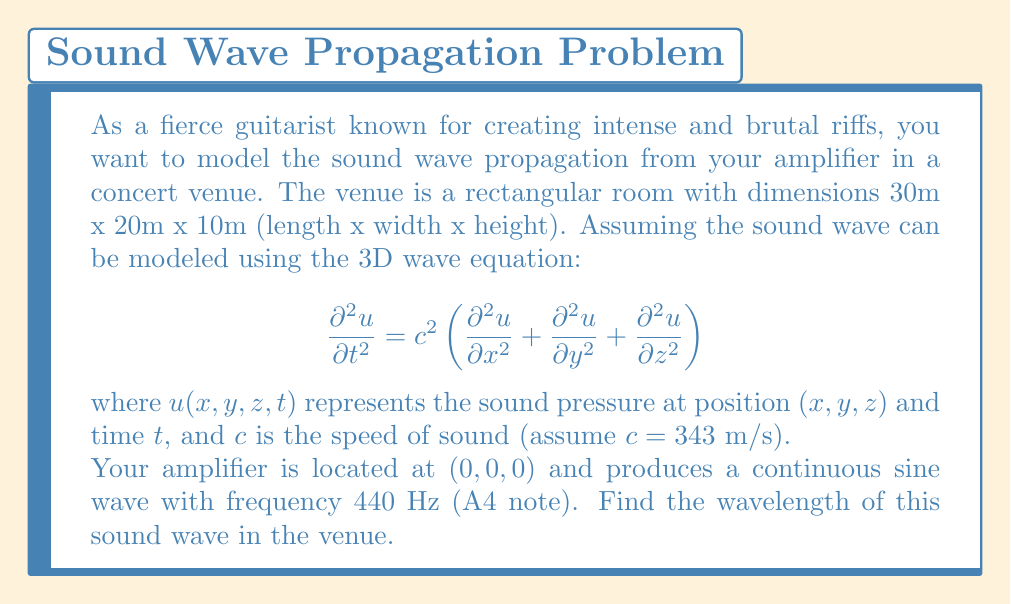Provide a solution to this math problem. To solve this problem, we need to understand the relationship between frequency, wavelength, and the speed of sound. The wave equation given describes how the sound wave propagates in three-dimensional space.

1) First, recall the relationship between frequency ($f$), wavelength ($\lambda$), and wave speed ($c$):

   $$c = f \lambda$$

2) We are given:
   - Frequency, $f = 440$ Hz
   - Speed of sound, $c = 343$ m/s

3) Rearranging the equation to solve for wavelength:

   $$\lambda = \frac{c}{f}$$

4) Substituting the values:

   $$\lambda = \frac{343 \text{ m/s}}{440 \text{ Hz}}$$

5) Simplifying:

   $$\lambda = 0.77954545... \text{ m}$$

6) Rounding to three decimal places:

   $$\lambda \approx 0.780 \text{ m}$$

This wavelength represents the spatial period of the sound wave as it propagates through the concert venue. It's worth noting that while the wave equation describes the propagation, the wavelength itself is independent of the room dimensions in this idealized model.
Answer: $\lambda \approx 0.780 \text{ m}$ 